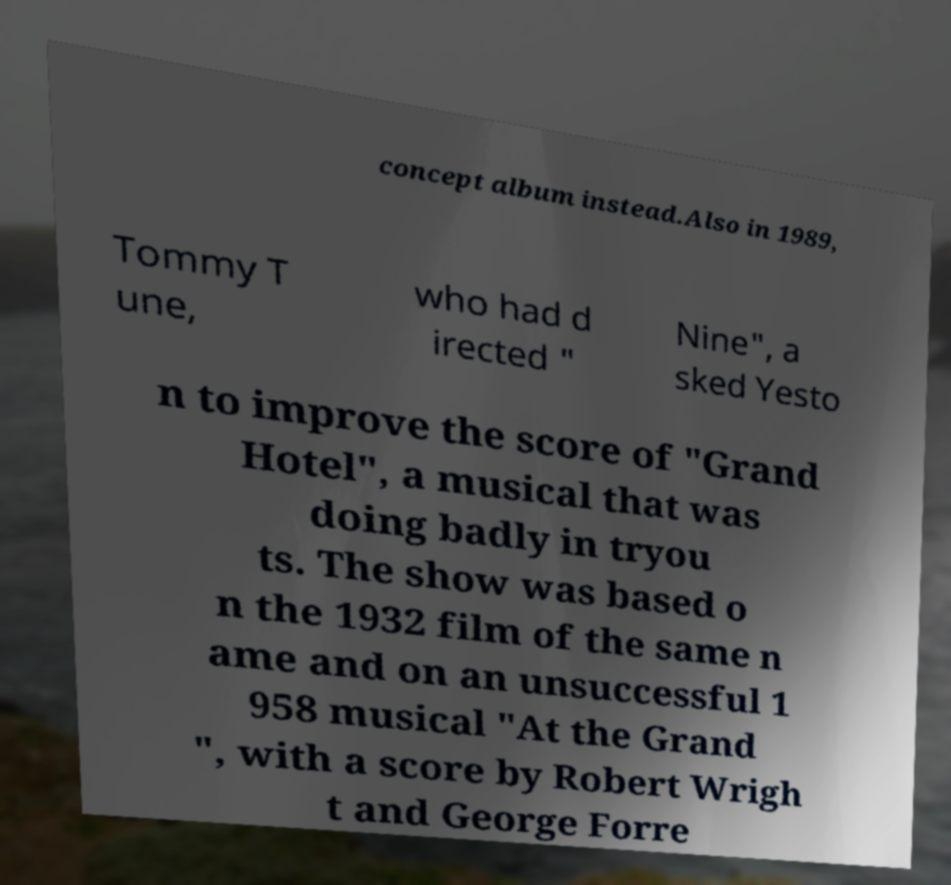Could you extract and type out the text from this image? concept album instead.Also in 1989, Tommy T une, who had d irected " Nine", a sked Yesto n to improve the score of "Grand Hotel", a musical that was doing badly in tryou ts. The show was based o n the 1932 film of the same n ame and on an unsuccessful 1 958 musical "At the Grand ", with a score by Robert Wrigh t and George Forre 